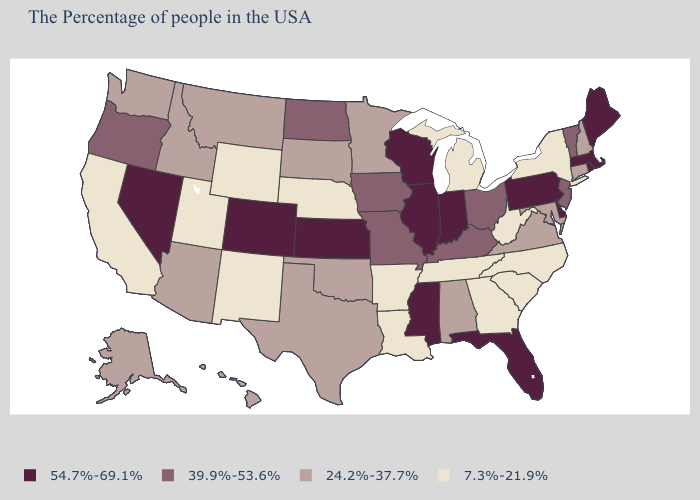Does the first symbol in the legend represent the smallest category?
Give a very brief answer. No. What is the highest value in states that border Alabama?
Quick response, please. 54.7%-69.1%. What is the highest value in the Northeast ?
Concise answer only. 54.7%-69.1%. What is the value of New Jersey?
Keep it brief. 39.9%-53.6%. Does Missouri have a higher value than North Carolina?
Keep it brief. Yes. Among the states that border Oklahoma , which have the highest value?
Give a very brief answer. Kansas, Colorado. Which states hav the highest value in the West?
Be succinct. Colorado, Nevada. Does the map have missing data?
Short answer required. No. What is the value of Idaho?
Be succinct. 24.2%-37.7%. Among the states that border New York , does Massachusetts have the highest value?
Keep it brief. Yes. What is the highest value in the West ?
Quick response, please. 54.7%-69.1%. Name the states that have a value in the range 39.9%-53.6%?
Give a very brief answer. Vermont, New Jersey, Ohio, Kentucky, Missouri, Iowa, North Dakota, Oregon. Name the states that have a value in the range 54.7%-69.1%?
Give a very brief answer. Maine, Massachusetts, Rhode Island, Delaware, Pennsylvania, Florida, Indiana, Wisconsin, Illinois, Mississippi, Kansas, Colorado, Nevada. What is the value of Colorado?
Quick response, please. 54.7%-69.1%. What is the highest value in the South ?
Write a very short answer. 54.7%-69.1%. 